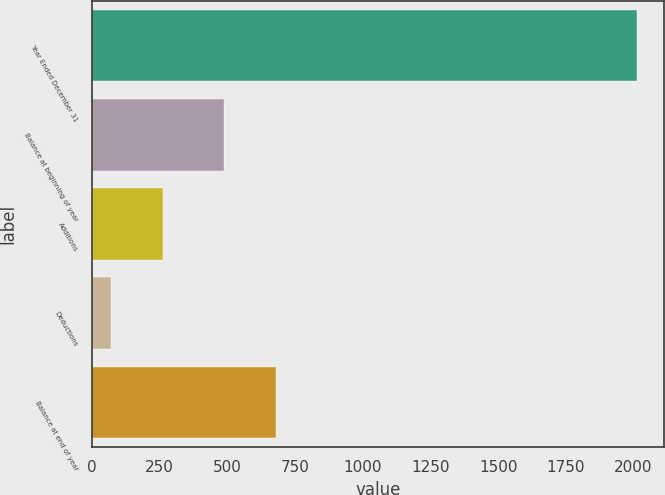Convert chart to OTSL. <chart><loc_0><loc_0><loc_500><loc_500><bar_chart><fcel>Year Ended December 31<fcel>Balance at beginning of year<fcel>Additions<fcel>Deductions<fcel>Balance at end of year<nl><fcel>2013<fcel>487<fcel>264.3<fcel>70<fcel>681.3<nl></chart> 